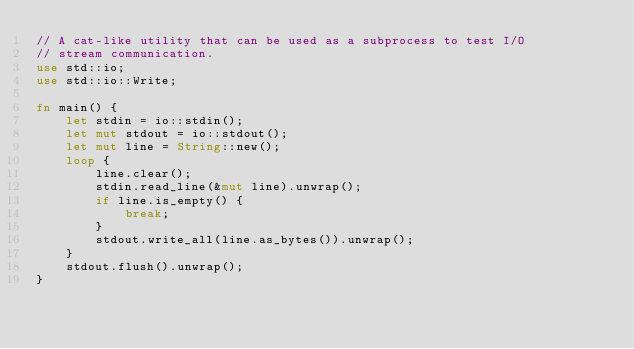<code> <loc_0><loc_0><loc_500><loc_500><_Rust_>// A cat-like utility that can be used as a subprocess to test I/O
// stream communication.
use std::io;
use std::io::Write;

fn main() {
    let stdin = io::stdin();
    let mut stdout = io::stdout();
    let mut line = String::new();
    loop {
        line.clear();
        stdin.read_line(&mut line).unwrap();
        if line.is_empty() {
            break;
        }
        stdout.write_all(line.as_bytes()).unwrap();
    }
    stdout.flush().unwrap();
}
</code> 